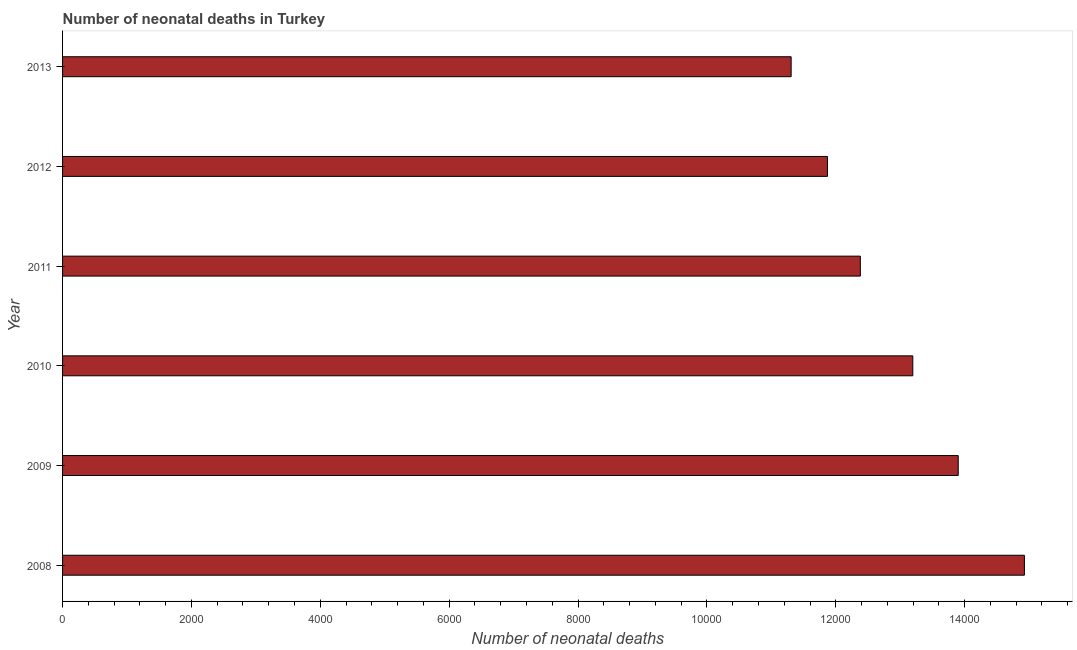Does the graph contain grids?
Offer a very short reply. No. What is the title of the graph?
Provide a short and direct response. Number of neonatal deaths in Turkey. What is the label or title of the X-axis?
Offer a terse response. Number of neonatal deaths. What is the number of neonatal deaths in 2008?
Your answer should be compact. 1.49e+04. Across all years, what is the maximum number of neonatal deaths?
Ensure brevity in your answer.  1.49e+04. Across all years, what is the minimum number of neonatal deaths?
Your answer should be compact. 1.13e+04. In which year was the number of neonatal deaths maximum?
Your answer should be very brief. 2008. In which year was the number of neonatal deaths minimum?
Ensure brevity in your answer.  2013. What is the sum of the number of neonatal deaths?
Provide a short and direct response. 7.76e+04. What is the difference between the number of neonatal deaths in 2010 and 2012?
Give a very brief answer. 1324. What is the average number of neonatal deaths per year?
Make the answer very short. 1.29e+04. What is the median number of neonatal deaths?
Offer a terse response. 1.28e+04. In how many years, is the number of neonatal deaths greater than 5200 ?
Offer a very short reply. 6. Do a majority of the years between 2010 and 2013 (inclusive) have number of neonatal deaths greater than 11600 ?
Your answer should be very brief. Yes. What is the ratio of the number of neonatal deaths in 2008 to that in 2013?
Provide a succinct answer. 1.32. Is the difference between the number of neonatal deaths in 2008 and 2009 greater than the difference between any two years?
Ensure brevity in your answer.  No. What is the difference between the highest and the second highest number of neonatal deaths?
Make the answer very short. 1027. What is the difference between the highest and the lowest number of neonatal deaths?
Offer a terse response. 3620. In how many years, is the number of neonatal deaths greater than the average number of neonatal deaths taken over all years?
Keep it short and to the point. 3. Are all the bars in the graph horizontal?
Keep it short and to the point. Yes. How many years are there in the graph?
Offer a very short reply. 6. What is the difference between two consecutive major ticks on the X-axis?
Provide a short and direct response. 2000. What is the Number of neonatal deaths of 2008?
Offer a very short reply. 1.49e+04. What is the Number of neonatal deaths in 2009?
Offer a very short reply. 1.39e+04. What is the Number of neonatal deaths of 2010?
Offer a very short reply. 1.32e+04. What is the Number of neonatal deaths in 2011?
Offer a very short reply. 1.24e+04. What is the Number of neonatal deaths in 2012?
Give a very brief answer. 1.19e+04. What is the Number of neonatal deaths of 2013?
Ensure brevity in your answer.  1.13e+04. What is the difference between the Number of neonatal deaths in 2008 and 2009?
Your response must be concise. 1027. What is the difference between the Number of neonatal deaths in 2008 and 2010?
Your answer should be very brief. 1732. What is the difference between the Number of neonatal deaths in 2008 and 2011?
Give a very brief answer. 2546. What is the difference between the Number of neonatal deaths in 2008 and 2012?
Offer a terse response. 3056. What is the difference between the Number of neonatal deaths in 2008 and 2013?
Your response must be concise. 3620. What is the difference between the Number of neonatal deaths in 2009 and 2010?
Offer a very short reply. 705. What is the difference between the Number of neonatal deaths in 2009 and 2011?
Provide a succinct answer. 1519. What is the difference between the Number of neonatal deaths in 2009 and 2012?
Your response must be concise. 2029. What is the difference between the Number of neonatal deaths in 2009 and 2013?
Provide a succinct answer. 2593. What is the difference between the Number of neonatal deaths in 2010 and 2011?
Make the answer very short. 814. What is the difference between the Number of neonatal deaths in 2010 and 2012?
Make the answer very short. 1324. What is the difference between the Number of neonatal deaths in 2010 and 2013?
Provide a succinct answer. 1888. What is the difference between the Number of neonatal deaths in 2011 and 2012?
Offer a terse response. 510. What is the difference between the Number of neonatal deaths in 2011 and 2013?
Provide a short and direct response. 1074. What is the difference between the Number of neonatal deaths in 2012 and 2013?
Provide a succinct answer. 564. What is the ratio of the Number of neonatal deaths in 2008 to that in 2009?
Your response must be concise. 1.07. What is the ratio of the Number of neonatal deaths in 2008 to that in 2010?
Provide a short and direct response. 1.13. What is the ratio of the Number of neonatal deaths in 2008 to that in 2011?
Ensure brevity in your answer.  1.21. What is the ratio of the Number of neonatal deaths in 2008 to that in 2012?
Give a very brief answer. 1.26. What is the ratio of the Number of neonatal deaths in 2008 to that in 2013?
Offer a very short reply. 1.32. What is the ratio of the Number of neonatal deaths in 2009 to that in 2010?
Your answer should be very brief. 1.05. What is the ratio of the Number of neonatal deaths in 2009 to that in 2011?
Your answer should be very brief. 1.12. What is the ratio of the Number of neonatal deaths in 2009 to that in 2012?
Provide a short and direct response. 1.17. What is the ratio of the Number of neonatal deaths in 2009 to that in 2013?
Offer a very short reply. 1.23. What is the ratio of the Number of neonatal deaths in 2010 to that in 2011?
Your answer should be compact. 1.07. What is the ratio of the Number of neonatal deaths in 2010 to that in 2012?
Offer a very short reply. 1.11. What is the ratio of the Number of neonatal deaths in 2010 to that in 2013?
Ensure brevity in your answer.  1.17. What is the ratio of the Number of neonatal deaths in 2011 to that in 2012?
Ensure brevity in your answer.  1.04. What is the ratio of the Number of neonatal deaths in 2011 to that in 2013?
Your answer should be compact. 1.09. What is the ratio of the Number of neonatal deaths in 2012 to that in 2013?
Make the answer very short. 1.05. 